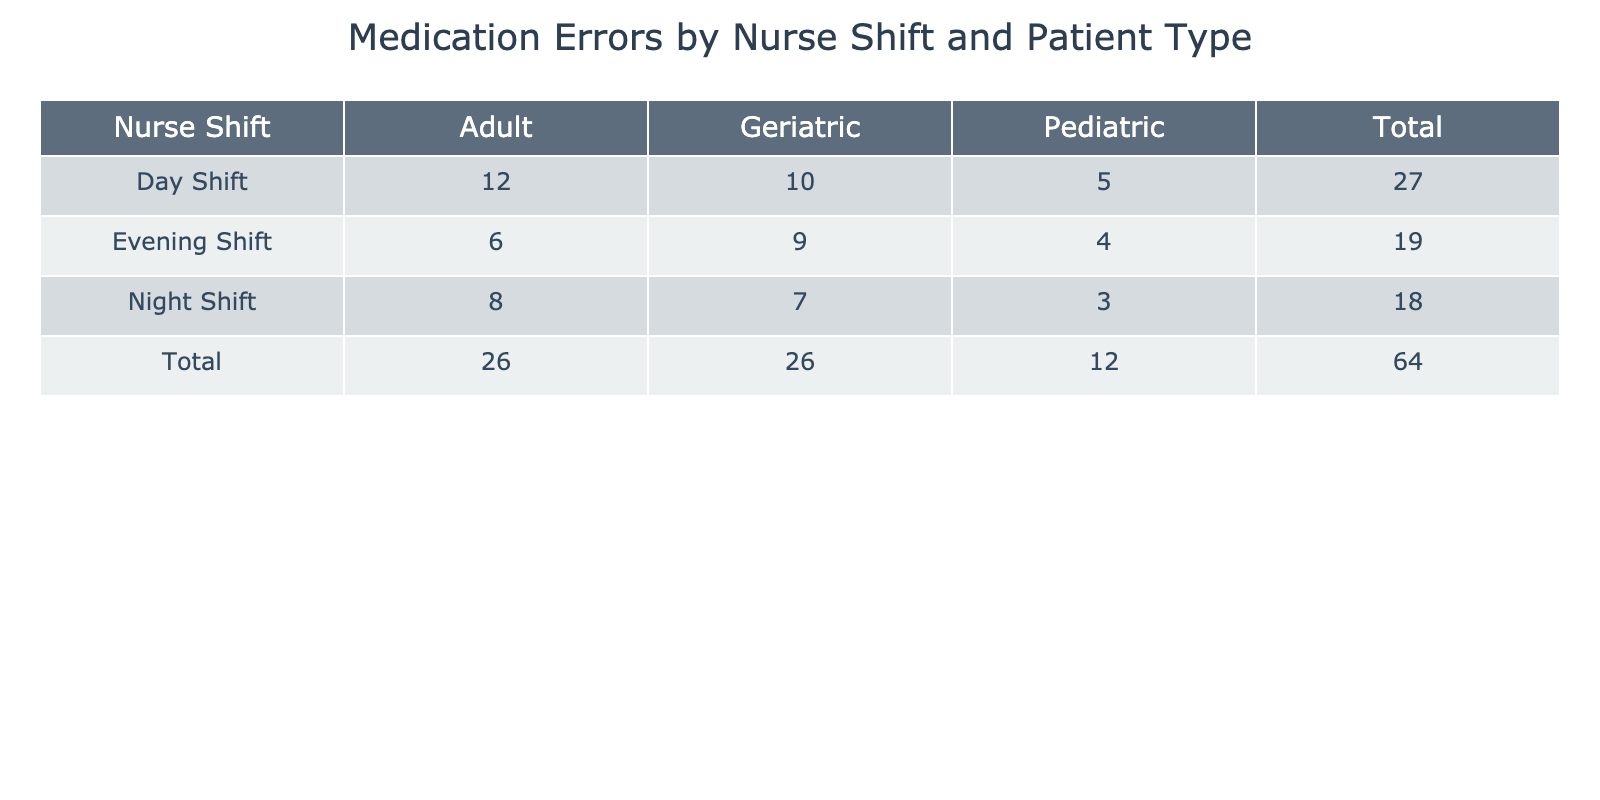What is the total number of medication errors for Day Shift? For Day Shift, there are three patient types: Adult (12), Pediatric (5), and Geriatric (10). To find the total for Day Shift, we add these values: 12 + 5 + 10 = 27.
Answer: 27 Which nurse shift had the highest number of medication errors for Pediatric patients? Looking at the Pediatric row for each nurse shift, Day Shift had 5 errors, Night Shift had 3 errors, and Evening Shift had 4 errors. The highest is 5 from Day Shift.
Answer: Day Shift Are there more medication errors for Adults than for Geriatric patients during Night Shift? During Night Shift, there are 8 medication errors for Adults and 7 for Geriatric patients. Since 8 is greater than 7, the statement is true.
Answer: Yes What is the average number of medication errors across all shifts for Geriatric patients? The total for Geriatric patients across shifts is Adult (10), Night Shift (7), and Evening Shift (9), which adds up to 26. There are three shifts, so we divide 26 by 3: 26 / 3 = 8.67.
Answer: 8.67 Which patient type has the least total number of medication errors overall? To find the least total, we sum errors for each patient type: Adult (12 + 8 + 6 = 26), Pediatric (5 + 3 + 4 = 12), Geriatric (10 + 7 + 9 = 26). Pediatric has the lowest total of 12.
Answer: Pediatric What is the difference in medication errors between the highest and lowest patient type during Evening Shift? For Evening Shift, Adult patients had 6 errors, and Pediatric patients had 4 errors. The highest (Adult) minus the lowest (Pediatric) gives us 6 - 4 = 2.
Answer: 2 Does the Night Shift have a total number of medication errors greater than 20? For Night Shift, the total is Adult (8), Pediatric (3), and Geriatric (7), which sums to 8 + 3 + 7 = 18. Since 18 is less than 20, the answer is no.
Answer: No During which shift are the total medication errors for all patient types at their peak? The total medication errors by shift are: Day Shift (27), Night Shift (18), and Evening Shift (19). The highest total is for Day Shift with 27 errors.
Answer: Day Shift What is the total number of medication errors across all shifts? To find the total across all shifts, we sum all errors: Day Shift (27) + Night Shift (18) + Evening Shift (19) = 64.
Answer: 64 